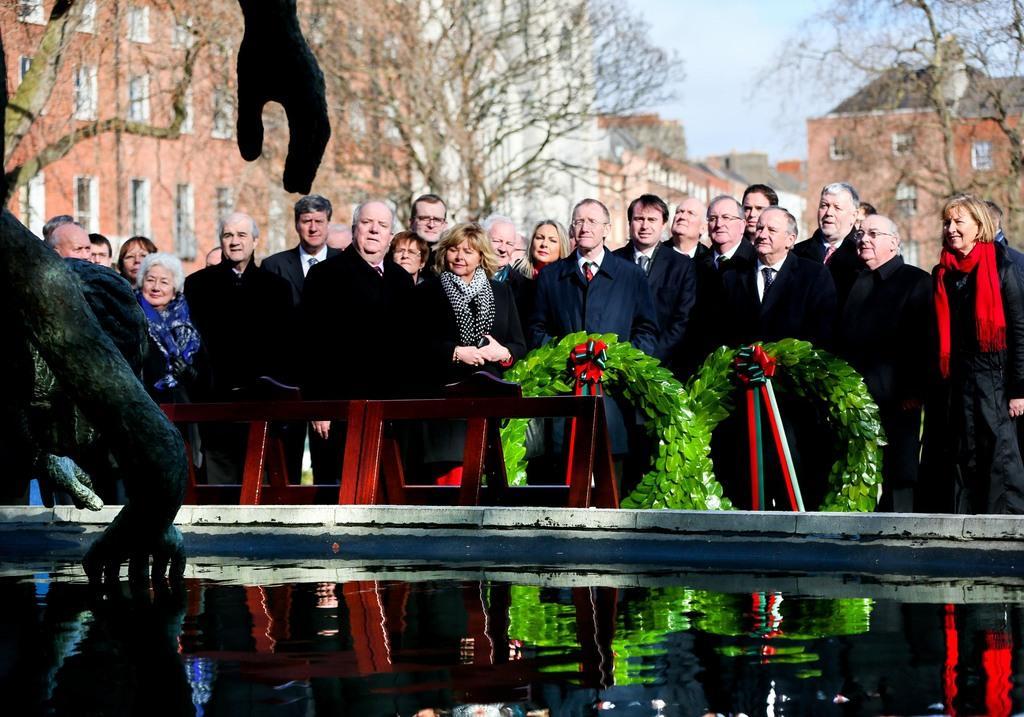How would you summarize this image in a sentence or two? In this image in the front there is water and there is a statue. In the center there are persons standing and there are objects which are green and red in colour. In the background there are trees and buildings. 